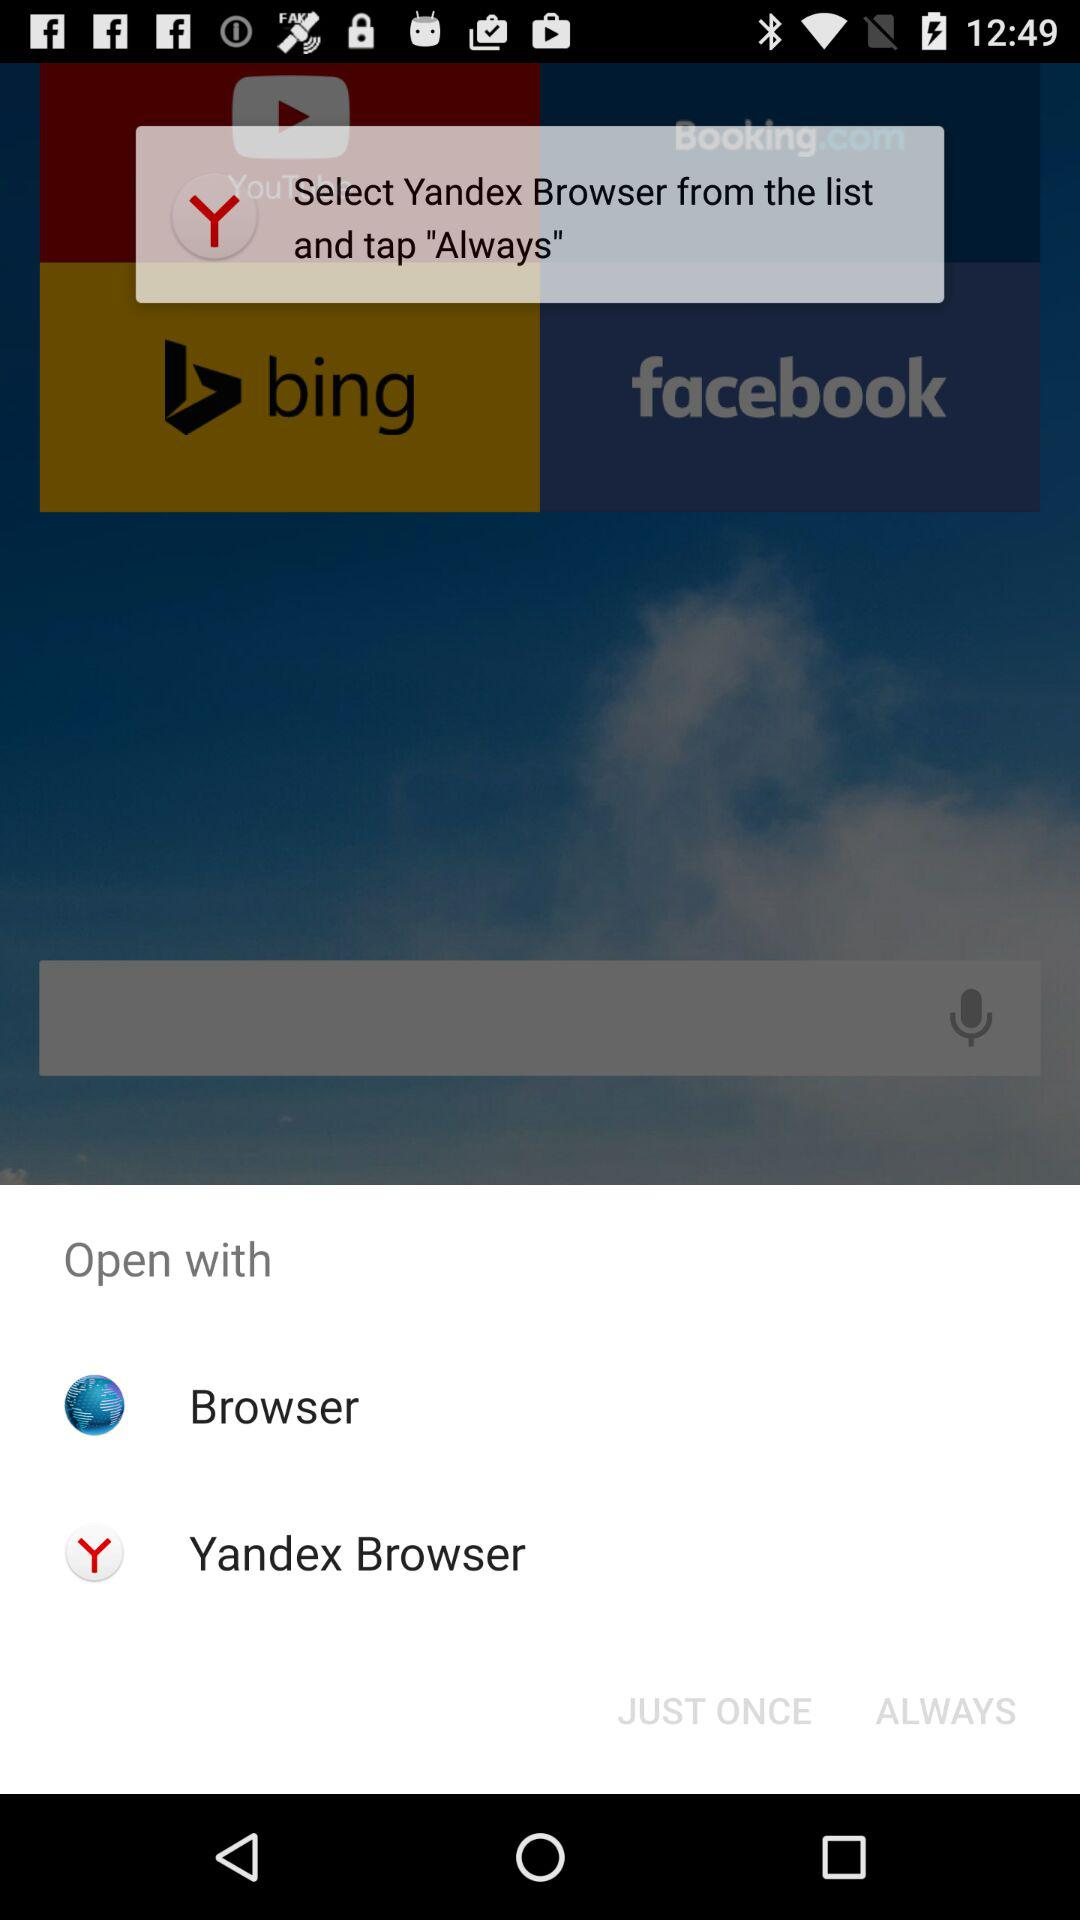Which application can we use to open? You can open with "Browser" and "Yandex Browser". 